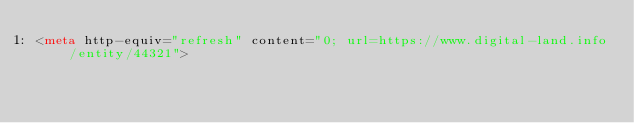<code> <loc_0><loc_0><loc_500><loc_500><_HTML_><meta http-equiv="refresh" content="0; url=https://www.digital-land.info/entity/44321"></code> 